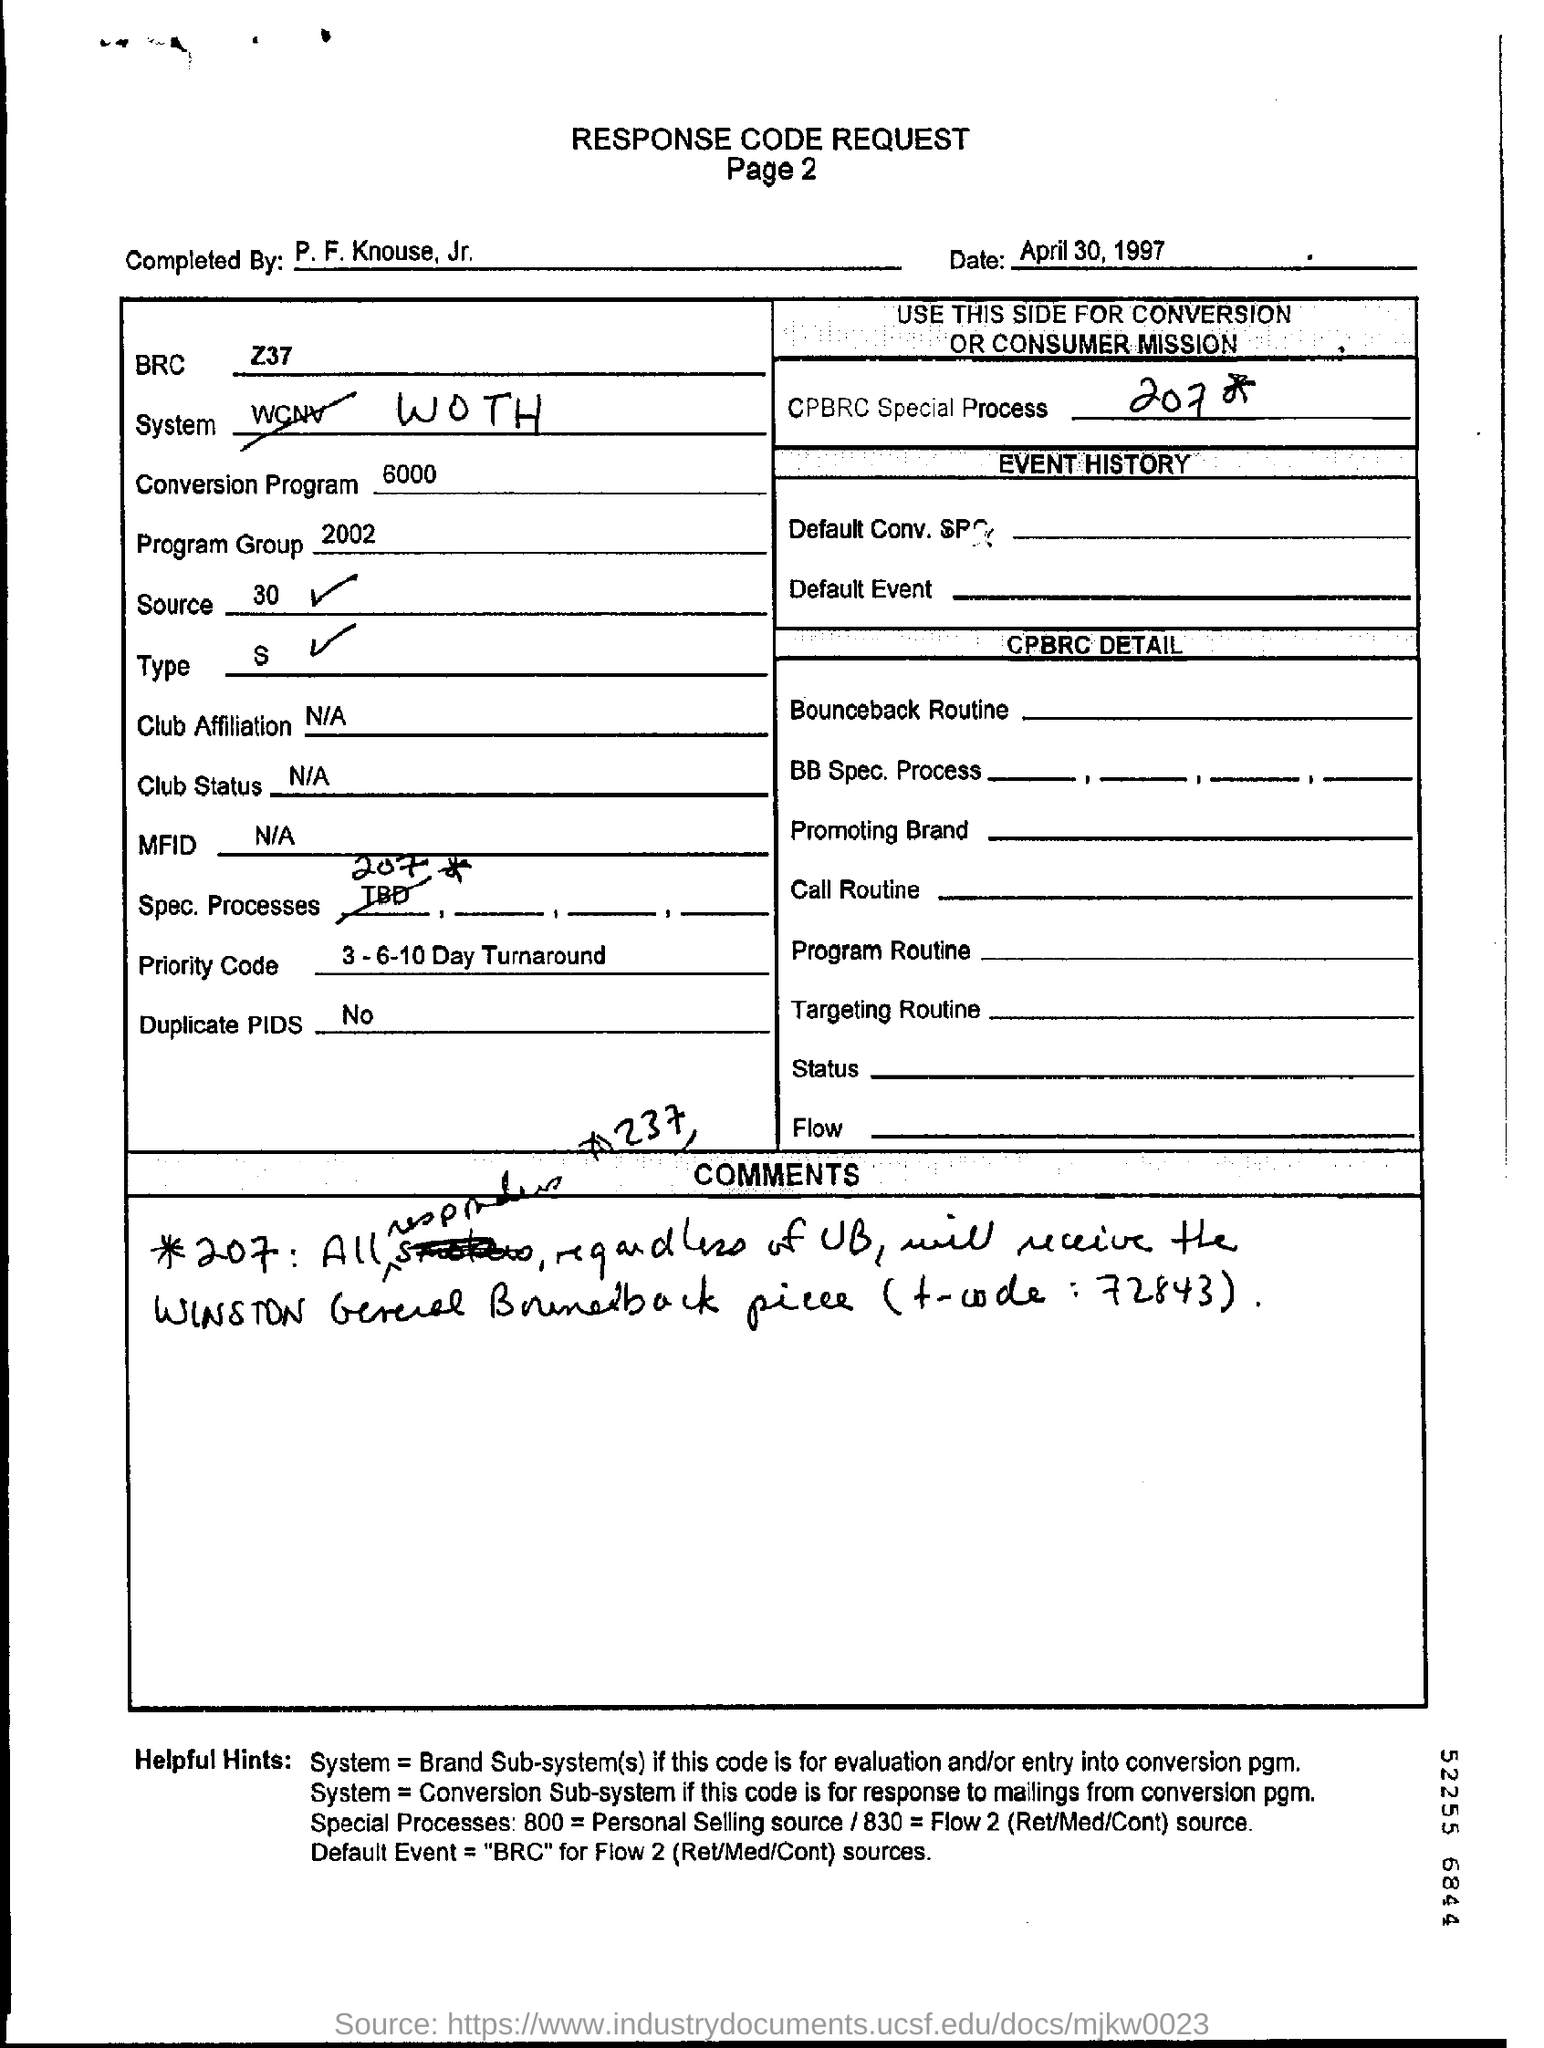What is the date mentioned ?
Provide a short and direct response. April 30 , 1997. What is mentioned  the cpbrc special process?
Provide a short and direct response. 207. What is mentioned in  the brc ?
Make the answer very short. Z37. What is the number that belongs to program group ?
Provide a short and direct response. 2002. What is mentioned in the conversion program ?
Make the answer very short. 6000. What is mentioned in the source?
Offer a very short reply. 30. 